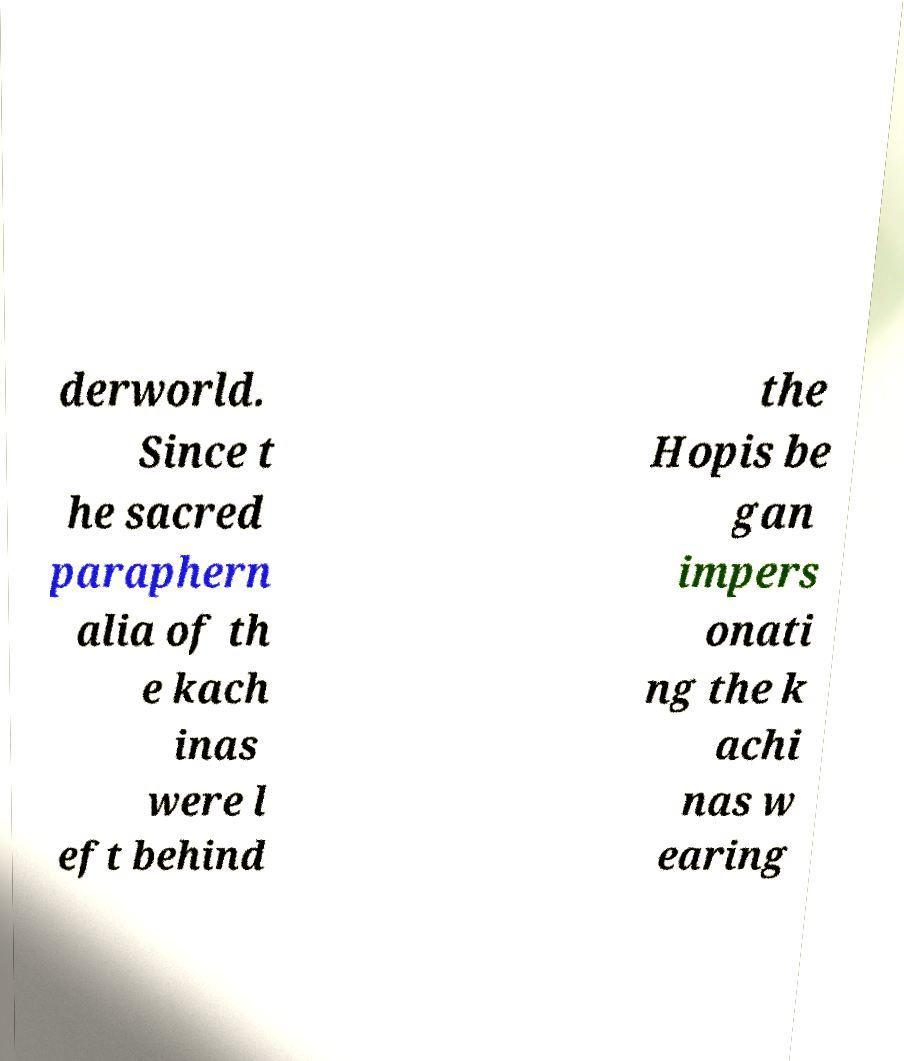Please read and relay the text visible in this image. What does it say? derworld. Since t he sacred paraphern alia of th e kach inas were l eft behind the Hopis be gan impers onati ng the k achi nas w earing 